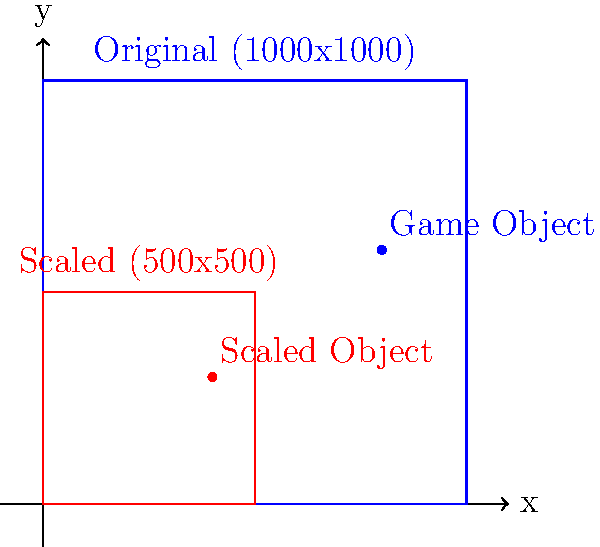In a game development project, you're tasked with translating the coordinates of game objects from the original screen resolution (1000x1000 pixels) to a new, scaled-down resolution (500x500 pixels). If a game object is originally positioned at coordinates (800, 600) on the 1000x1000 screen, what would be its new coordinates on the 500x500 screen? To solve this problem, we need to follow these steps:

1. Understand the scaling factor:
   - Original resolution: 1000x1000
   - New resolution: 500x500
   - Scaling factor = New resolution / Original resolution = 500/1000 = 1/2 or 0.5

2. Apply the scaling factor to both x and y coordinates:
   - Original x-coordinate: 800
   - Original y-coordinate: 600

3. Calculate new x-coordinate:
   $x_{new} = x_{original} \times \text{scaling factor}$
   $x_{new} = 800 \times 0.5 = 400$

4. Calculate new y-coordinate:
   $y_{new} = y_{original} \times \text{scaling factor}$
   $y_{new} = 600 \times 0.5 = 300$

5. Combine the new coordinates:
   New coordinates = (400, 300)

This scaling method ensures that the game object maintains its relative position on the screen, regardless of the display resolution.
Answer: (400, 300) 